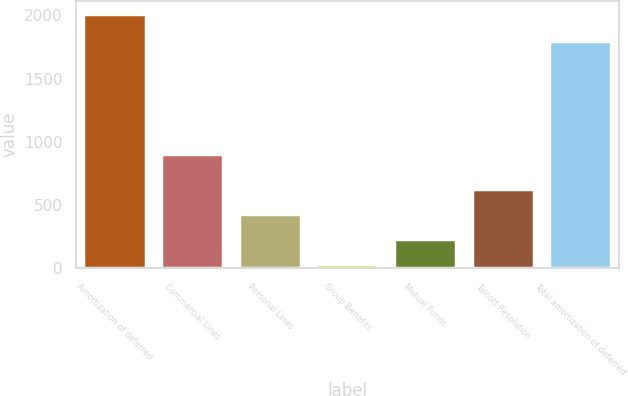Convert chart. <chart><loc_0><loc_0><loc_500><loc_500><bar_chart><fcel>Amortization of deferred<fcel>Commercial Lines<fcel>Personal Lines<fcel>Group Benefits<fcel>Mutual Funds<fcel>Talcott Resolution<fcel>Total amortization of deferred<nl><fcel>2013<fcel>905<fcel>429<fcel>33<fcel>231<fcel>627<fcel>1794<nl></chart> 